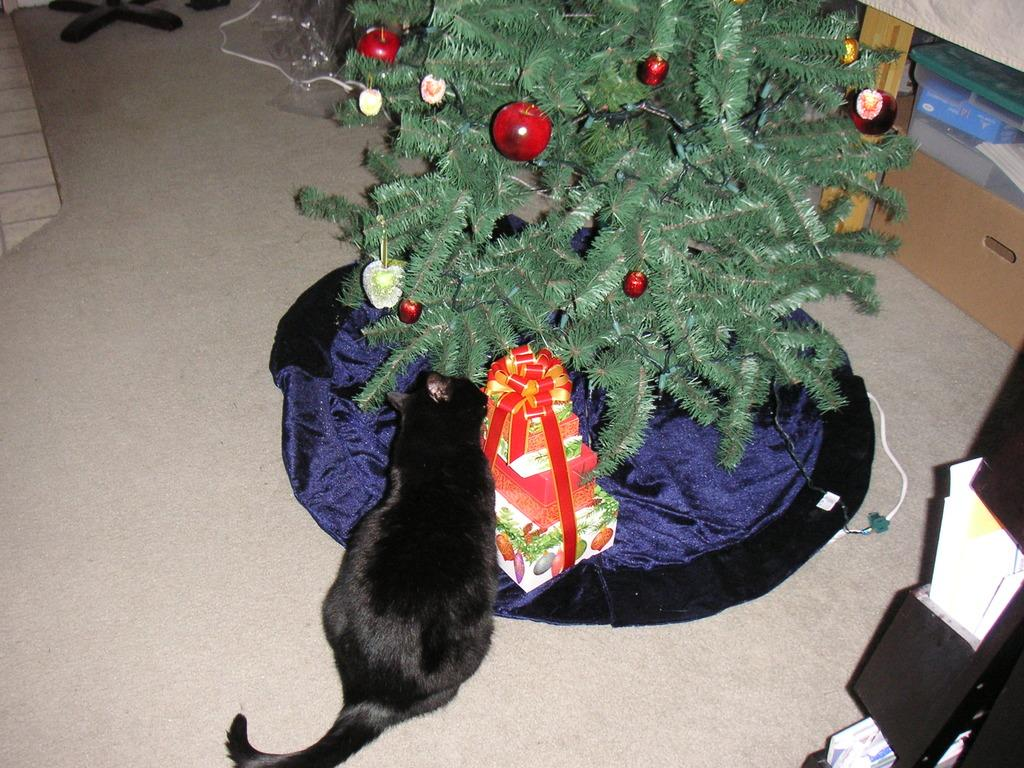What type of animal is in the image? There is a black cat in the image. Where is the cat located in the image? The cat is sitting on the floor. What is behind the cat in the image? The cat is in front of a Christmas tree. What is placed in front of the Christmas tree? There are presents in front of the Christmas tree. How are the presents arranged in the image? The presents are on a cloth. What can be seen in the background of the image? There are racks and cupboards in the background of the image. What type of lumber is being used to build the cat's house in the image? There is no cat's house present in the image, and therefore no lumber can be observed. How does the cat apply lipstick in the image? Cats do not use lipstick, and there is no lipstick present in the image. 